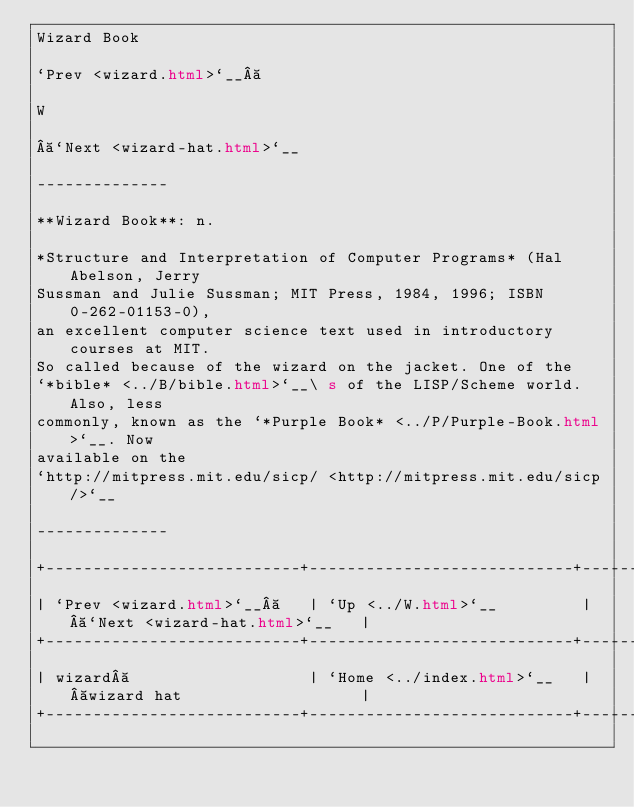<code> <loc_0><loc_0><loc_500><loc_500><_HTML_>Wizard Book

`Prev <wizard.html>`__ 

W

 `Next <wizard-hat.html>`__

--------------

**Wizard Book**: n.

*Structure and Interpretation of Computer Programs* (Hal Abelson, Jerry
Sussman and Julie Sussman; MIT Press, 1984, 1996; ISBN 0-262-01153-0),
an excellent computer science text used in introductory courses at MIT.
So called because of the wizard on the jacket. One of the
`*bible* <../B/bible.html>`__\ s of the LISP/Scheme world. Also, less
commonly, known as the `*Purple Book* <../P/Purple-Book.html>`__. Now
available on the
`http://mitpress.mit.edu/sicp/ <http://mitpress.mit.edu/sicp/>`__

--------------

+---------------------------+----------------------------+-------------------------------+
| `Prev <wizard.html>`__    | `Up <../W.html>`__         |  `Next <wizard-hat.html>`__   |
+---------------------------+----------------------------+-------------------------------+
| wizard                    | `Home <../index.html>`__   |  wizard hat                   |
+---------------------------+----------------------------+-------------------------------+

</code> 